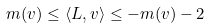Convert formula to latex. <formula><loc_0><loc_0><loc_500><loc_500>m ( v ) \leq \langle L , v \rangle \leq - m ( v ) - 2</formula> 